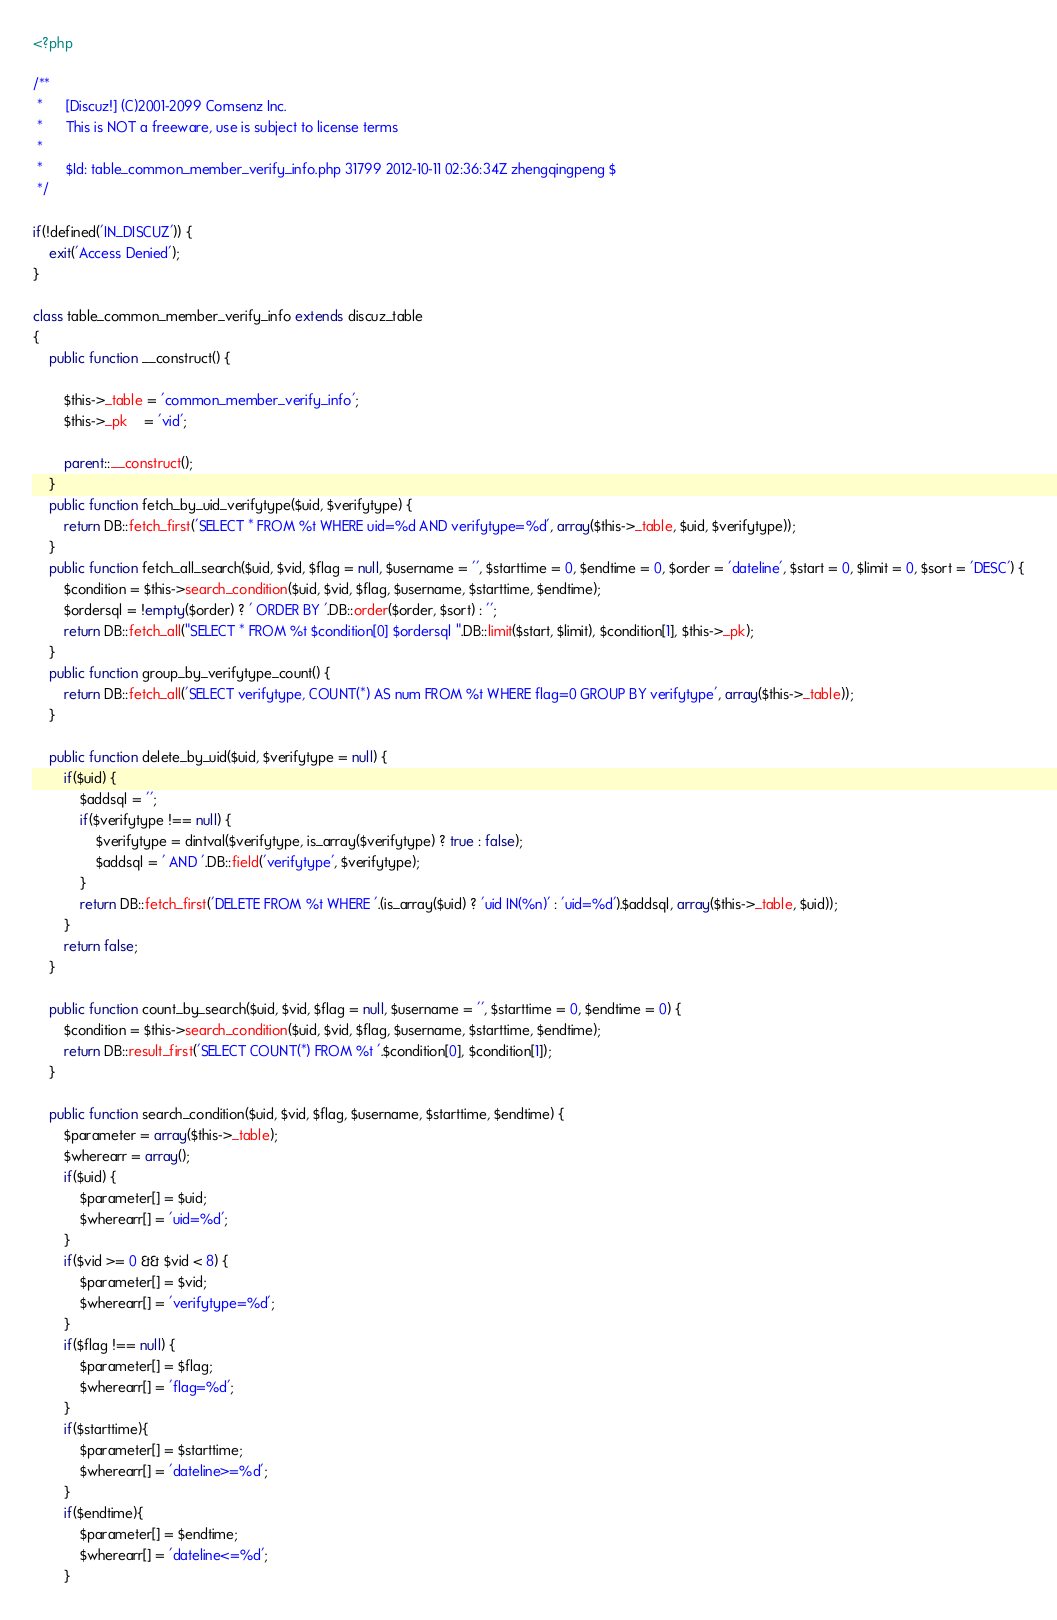<code> <loc_0><loc_0><loc_500><loc_500><_PHP_><?php

/**
 *      [Discuz!] (C)2001-2099 Comsenz Inc.
 *      This is NOT a freeware, use is subject to license terms
 *
 *      $Id: table_common_member_verify_info.php 31799 2012-10-11 02:36:34Z zhengqingpeng $
 */

if(!defined('IN_DISCUZ')) {
	exit('Access Denied');
}

class table_common_member_verify_info extends discuz_table
{
	public function __construct() {

		$this->_table = 'common_member_verify_info';
		$this->_pk    = 'vid';

		parent::__construct();
	}
	public function fetch_by_uid_verifytype($uid, $verifytype) {
		return DB::fetch_first('SELECT * FROM %t WHERE uid=%d AND verifytype=%d', array($this->_table, $uid, $verifytype));
	}
	public function fetch_all_search($uid, $vid, $flag = null, $username = '', $starttime = 0, $endtime = 0, $order = 'dateline', $start = 0, $limit = 0, $sort = 'DESC') {
		$condition = $this->search_condition($uid, $vid, $flag, $username, $starttime, $endtime);
		$ordersql = !empty($order) ? ' ORDER BY '.DB::order($order, $sort) : '';
		return DB::fetch_all("SELECT * FROM %t $condition[0] $ordersql ".DB::limit($start, $limit), $condition[1], $this->_pk);
	}
	public function group_by_verifytype_count() {
		return DB::fetch_all('SELECT verifytype, COUNT(*) AS num FROM %t WHERE flag=0 GROUP BY verifytype', array($this->_table));
	}

	public function delete_by_uid($uid, $verifytype = null) {
		if($uid) {
			$addsql = '';
			if($verifytype !== null) {
				$verifytype = dintval($verifytype, is_array($verifytype) ? true : false);
				$addsql = ' AND '.DB::field('verifytype', $verifytype);
			}
			return DB::fetch_first('DELETE FROM %t WHERE '.(is_array($uid) ? 'uid IN(%n)' : 'uid=%d').$addsql, array($this->_table, $uid));
		}
		return false;
	}

	public function count_by_search($uid, $vid, $flag = null, $username = '', $starttime = 0, $endtime = 0) {
		$condition = $this->search_condition($uid, $vid, $flag, $username, $starttime, $endtime);
		return DB::result_first('SELECT COUNT(*) FROM %t '.$condition[0], $condition[1]);
	}

	public function search_condition($uid, $vid, $flag, $username, $starttime, $endtime) {
		$parameter = array($this->_table);
		$wherearr = array();
		if($uid) {
			$parameter[] = $uid;
			$wherearr[] = 'uid=%d';
		}
		if($vid >= 0 && $vid < 8) {
			$parameter[] = $vid;
			$wherearr[] = 'verifytype=%d';
		}
		if($flag !== null) {
			$parameter[] = $flag;
			$wherearr[] = 'flag=%d';
		}
		if($starttime){
			$parameter[] = $starttime;
			$wherearr[] = 'dateline>=%d';
		}
		if($endtime){
			$parameter[] = $endtime;
			$wherearr[] = 'dateline<=%d';
		}</code> 